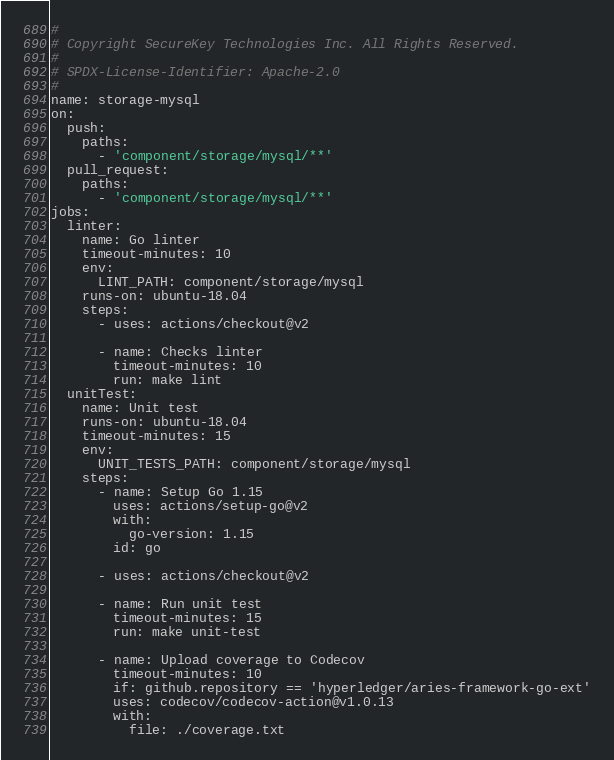Convert code to text. <code><loc_0><loc_0><loc_500><loc_500><_YAML_>#
# Copyright SecureKey Technologies Inc. All Rights Reserved.
#
# SPDX-License-Identifier: Apache-2.0
#
name: storage-mysql
on:
  push:
    paths:
      - 'component/storage/mysql/**'
  pull_request:
    paths:
      - 'component/storage/mysql/**'
jobs:
  linter:
    name: Go linter
    timeout-minutes: 10
    env:
      LINT_PATH: component/storage/mysql
    runs-on: ubuntu-18.04
    steps:
      - uses: actions/checkout@v2

      - name: Checks linter
        timeout-minutes: 10
        run: make lint
  unitTest:
    name: Unit test
    runs-on: ubuntu-18.04
    timeout-minutes: 15
    env:
      UNIT_TESTS_PATH: component/storage/mysql
    steps:
      - name: Setup Go 1.15
        uses: actions/setup-go@v2
        with:
          go-version: 1.15
        id: go

      - uses: actions/checkout@v2

      - name: Run unit test
        timeout-minutes: 15
        run: make unit-test

      - name: Upload coverage to Codecov
        timeout-minutes: 10
        if: github.repository == 'hyperledger/aries-framework-go-ext'
        uses: codecov/codecov-action@v1.0.13
        with:
          file: ./coverage.txt
</code> 